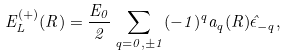Convert formula to latex. <formula><loc_0><loc_0><loc_500><loc_500>E _ { L } ^ { ( + ) } ( R ) = \frac { E _ { 0 } } { 2 } \sum _ { q = 0 , \pm 1 } ( - 1 ) ^ { q } a _ { q } ( R ) \hat { \epsilon } _ { - q } ,</formula> 